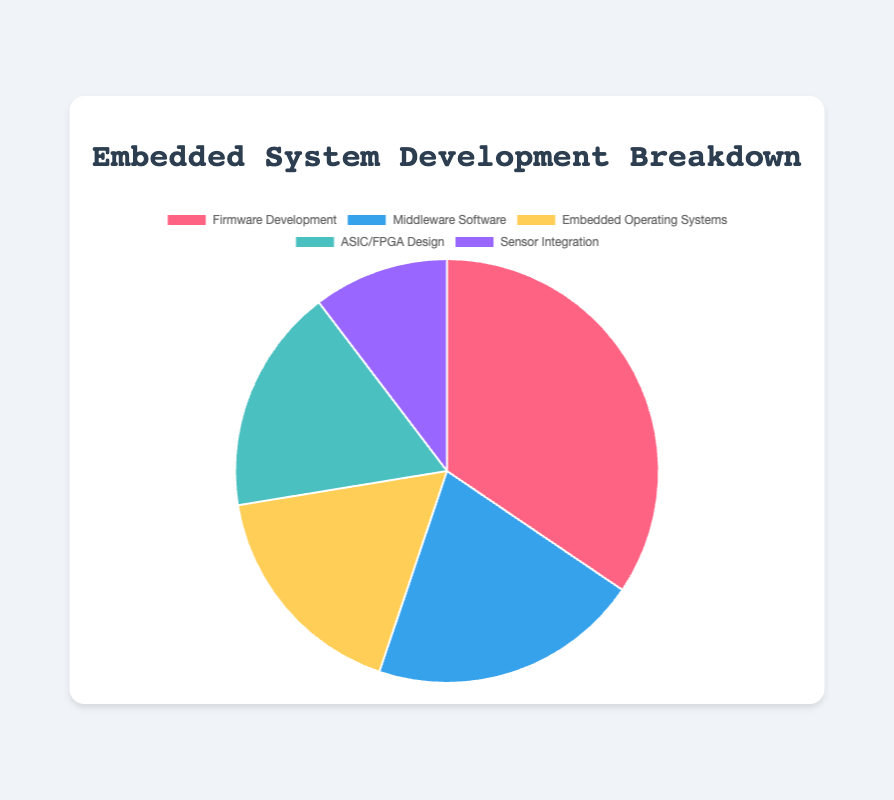Which category has the highest contribution? The category with the highest contribution can be determined by looking at the category with the largest slice in the pie chart. In this case, "Firmware Development" has the largest slice.
Answer: Firmware Development How does the contribution of Middleware Software compare to ASIC/FPGA Design? By looking at the sizes of the pie chart slices, we can see that both "Middleware Software" and "ASIC/FPGA Design" have relatively similar slice sizes. However, Middleware Software has a slightly larger share when we add up the contributions within each category. Middleware Software has 30 units, while ASIC/FPGA Design has 25 units.
Answer: Middleware Software is higher What is the combined contribution of Kernel Development and Task Scheduling? Kernel Development has a contribution of 10 units, and Task Scheduling has a contribution of 5 units. Adding these together gives 10 + 5 = 15 units.
Answer: 15 units Which category has a smaller contribution: Sensor Integration or Firmware Development? By comparing the slices in the pie chart, we can see that "Sensor Integration" has a much smaller slice compared to "Firmware Development". Specifically, Sensor Integration contributes 15 units in total while Firmware Development contributes 50 units.
Answer: Sensor Integration What percentage of the total contribution does Driver Development represent? Driver Development contributes 20 units. First, calculate the total contribution by summing all individual contributions. The total is \(10 + 20 + 15 + 5 + 10 + 10 + 5 + 5 + 10 + 5 + 5 + 5 + 5 + 5 + 5 = 120 \) units. The percentage can be calculated as \(\frac{20}{120} \times 100 = 16.67\%\).
Answer: 16.67% How do the contributions of Peripheral Initialization and Middleware Integration compare quantitatively? Peripheral Initialization and Middleware Integration each contribute 10 units. Since they have the same contribution, they are equal in their contributions.
Answer: Equal What is the difference in contribution between Communication Protocol Implementation and Software Libraries Development? Communication Protocol Implementation contributes 15 units, and Software Libraries Development contributes 5 units. The difference is calculated as \(15 - 5 = 10\) units.
Answer: 10 units What is the total contribution of the Embedded Operating Systems category? The total contribution for the Embedded Operating Systems category is calculated by summing up its individual contributions: \(10 + 5 + 5 + 5 = 25\) units.
Answer: 25 units 